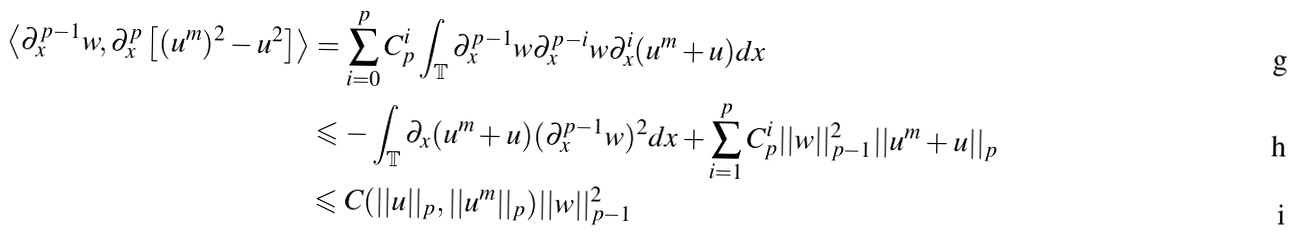Convert formula to latex. <formula><loc_0><loc_0><loc_500><loc_500>\left \langle \partial ^ { p - 1 } _ { x } w , \partial ^ { p } _ { x } \left [ ( u ^ { m } ) ^ { 2 } - u ^ { 2 } \right ] \right \rangle & = \sum _ { i = 0 } ^ { p } C _ { p } ^ { i } \int _ { \mathbb { T } } \partial ^ { p - 1 } _ { x } w \partial ^ { p - i } _ { x } w \partial ^ { i } _ { x } ( u ^ { m } + u ) d x \\ & \leqslant - \int _ { \mathbb { T } } \partial _ { x } ( u ^ { m } + u ) ( \partial ^ { p - 1 } _ { x } w ) ^ { 2 } d x + \sum _ { i = 1 } ^ { p } C _ { p } ^ { i } | | w | | _ { p - 1 } ^ { 2 } | | u ^ { m } + u | | _ { p } \\ & \leqslant C ( | | u | | _ { p } , | | u ^ { m } | | _ { p } ) | | w | | ^ { 2 } _ { p - 1 }</formula> 